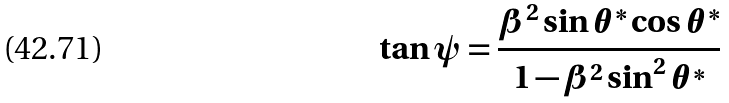Convert formula to latex. <formula><loc_0><loc_0><loc_500><loc_500>\tan \psi = \frac { \beta ^ { 2 } \sin \theta ^ { * } \cos \theta ^ { * } } { 1 - \beta ^ { 2 } \sin ^ { 2 } \theta ^ { * } }</formula> 